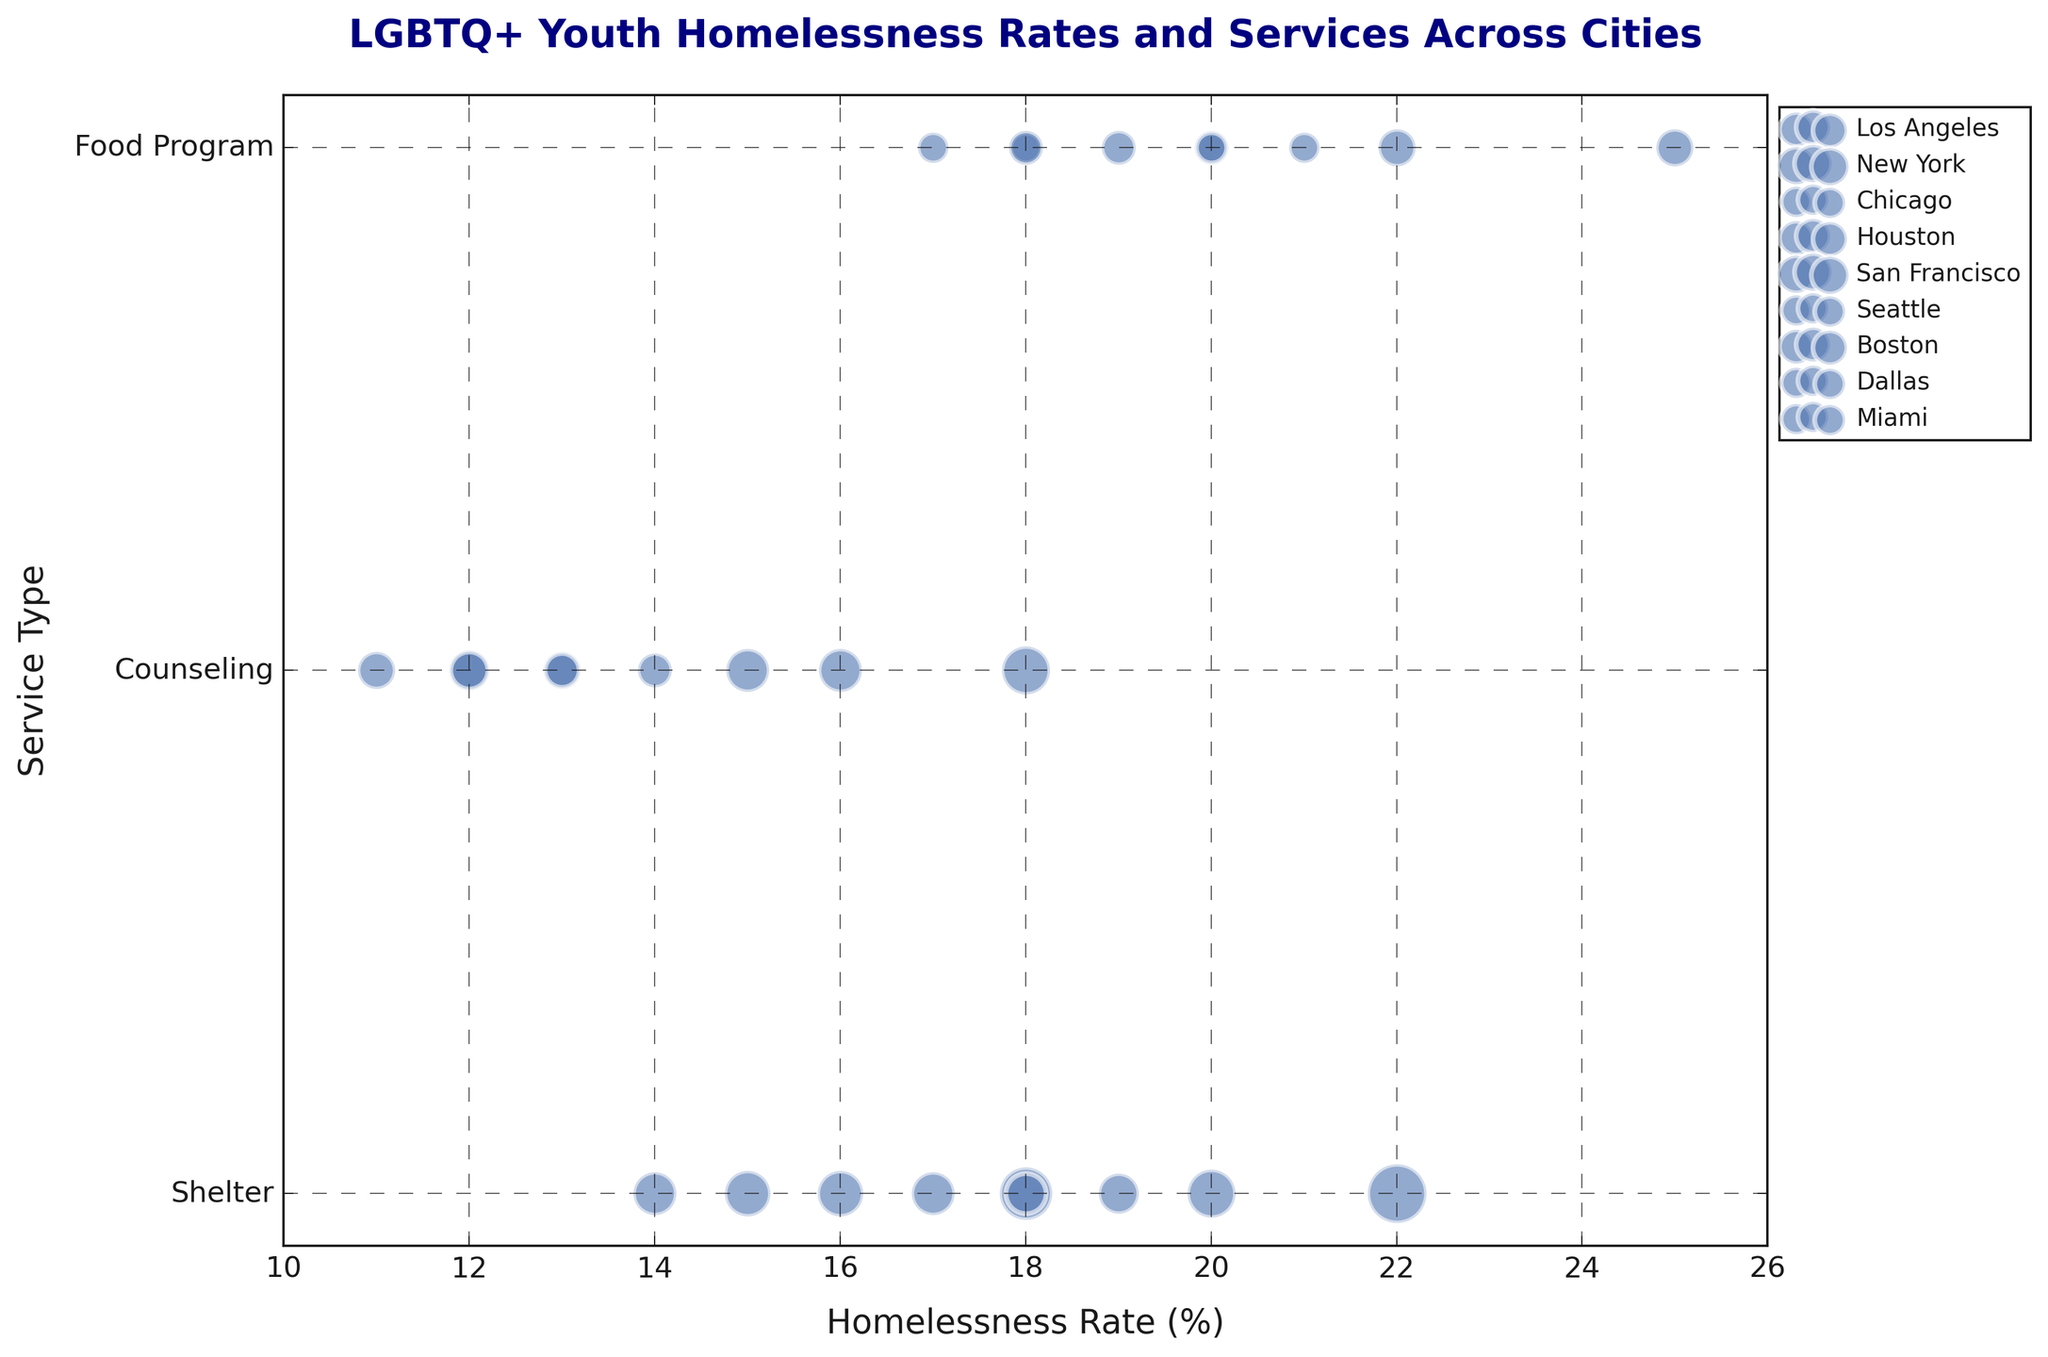What's the city with the highest homelessness rate for food programs? To find the city with the highest rate for food programs, look for the largest bubble along the horizontal axis under the "Food Program" category. According to the data, New York has a rate of 25%, the highest among all cities for that service.
Answer: New York Which city provides the most counseling services? To determine the city with the most counseling services, look for the largest bubble (most visually prominent) in the "Counseling" category. New York provides 10 counseling services, which is the highest value for this category.
Answer: New York Which cities have homelessness rates greater than 20% for any service type? Analyze the data points where the homelessness rate is greater than 20% for any service type. In this case, New York for Shelter and Food Program, San Francisco for Food Program, and Seattle for Food Program have rates over 20%.
Answer: New York, San Francisco, Seattle What's the total number of food programs provided across all cities? Calculate the sum of the number of food programs across all cities. The numbers are 5 (Los Angeles) + 6 (New York) + 4 (Chicago) + 5 (Houston) + 6 (San Francisco) + 4 (Seattle) + 5 (Boston) + 4 (Dallas) + 4 (Miami). The sum is 43.
Answer: 43 Is Los Angeles or Seattle offering more services in total? To determine which city offers more services in total, sum the total number of services provided in Los Angeles and Seattle respectively. Los Angeles: 12 (Shelter) + 8 (Counseling) + 5 (Food Program) = 25. Seattle: 7 (Shelter) + 5 (Counseling) + 4 (Food Program) = 16. Los Angeles offers more services than Seattle.
Answer: Los Angeles Which type of service in San Francisco has the highest rate of homelessness? Look for the category with the highest homelessness rate for San Francisco. The rates are 20% (Shelter), 16% (Counseling), and 22% (Food Program). Thus, the Food Program has the highest rate.
Answer: Food Program What's the difference in homelessness rates between shelter services in New York and Chicago? Compare the homelessness rates for shelter services between New York and Chicago. New York: 22%, Chicago: 15%. The difference is 22% - 15% = 7%.
Answer: 7% Which city has the smallest bubble in the counseling services category? Identify the smallest bubble visually in the "Counseling" category, which represents the least number of services provided. Dallas has only 6 counseling services, which is the smallest amount in that category.
Answer: Dallas 